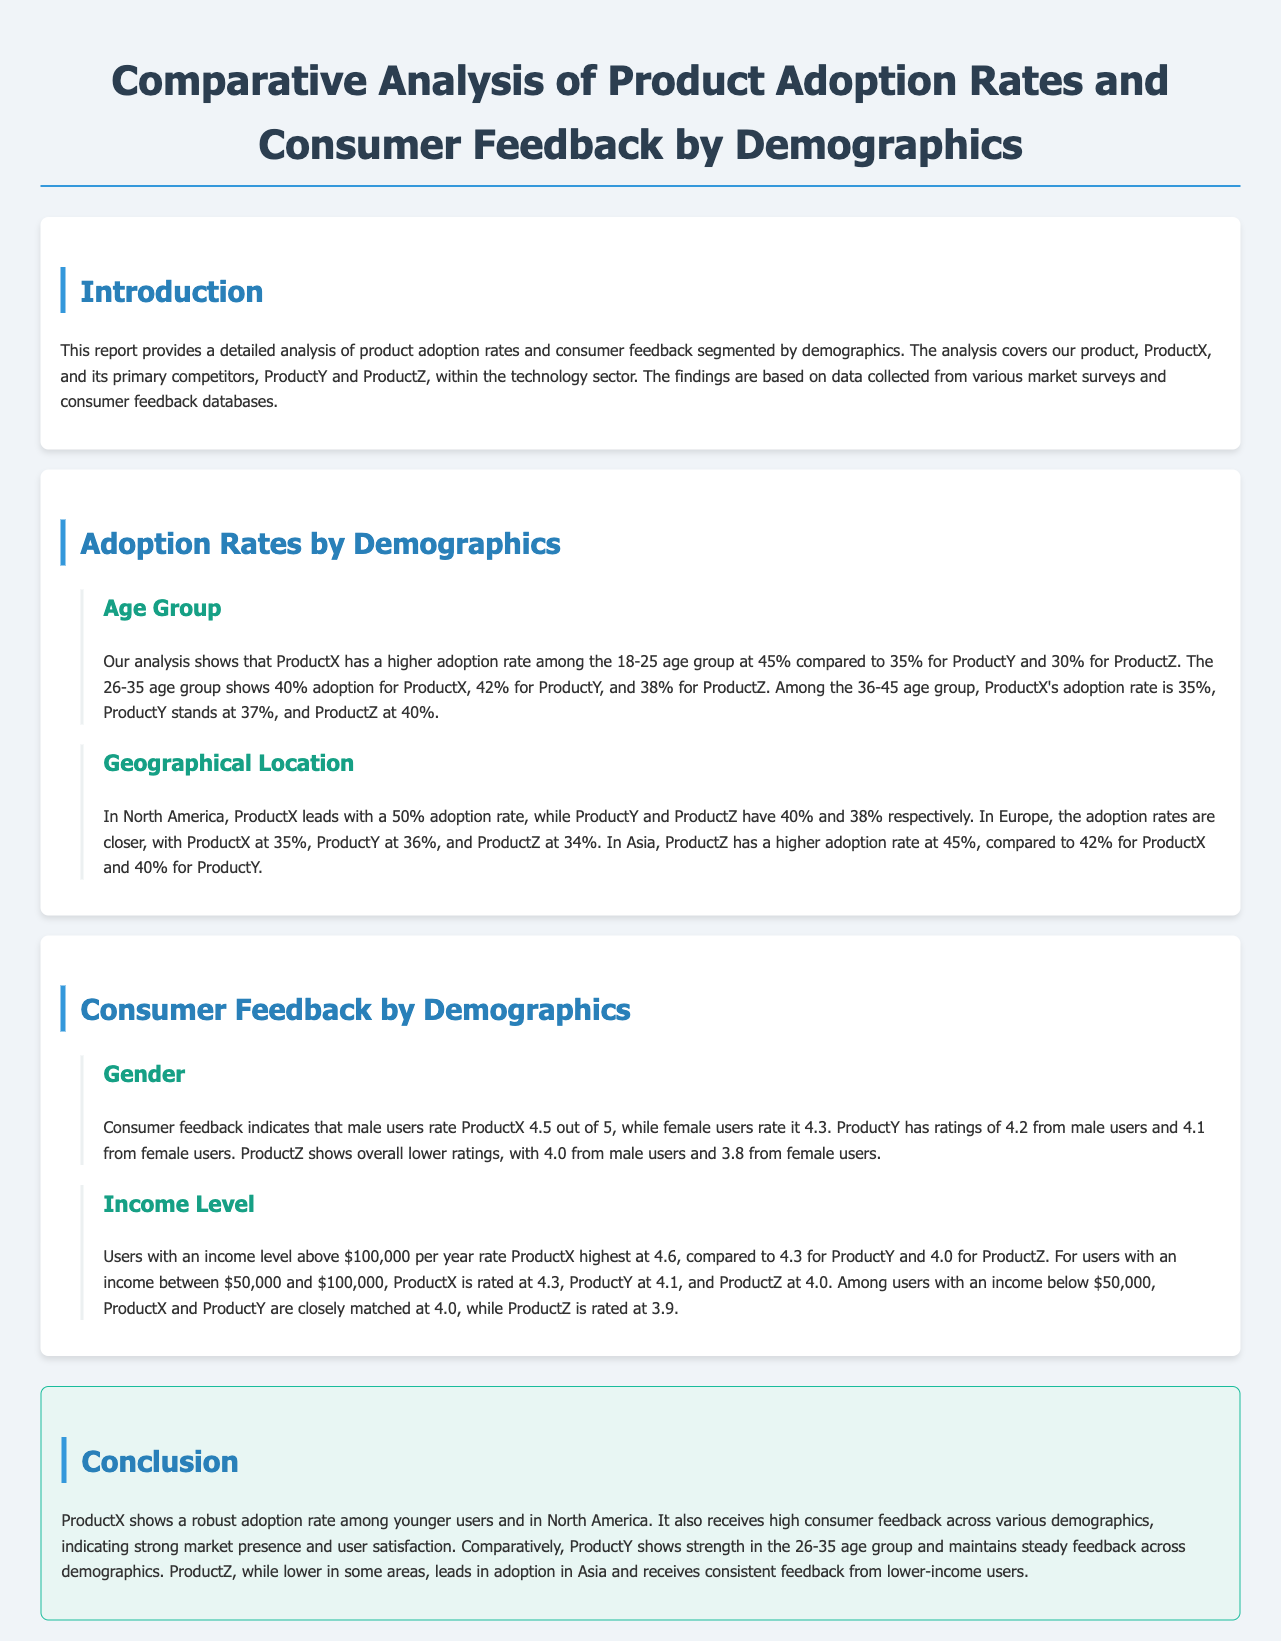What is the adoption rate of ProductX among the 18-25 age group? The document states that ProductX has a higher adoption rate among the 18-25 age group at 45%.
Answer: 45% What is the consumer rating of ProductY from male users? The document indicates that male users rate ProductY 4.2 out of 5.
Answer: 4.2 Which product has the highest adoption rate in North America? The analysis shows that ProductX leads with a 50% adoption rate in North America.
Answer: ProductX What is the rating of ProductX from users with an income above $100,000? It is mentioned that users with an income level above $100,000 per year rate ProductX highest at 4.6.
Answer: 4.6 In which geographical region does ProductZ have a higher adoption rate than ProductX? The document mentions that in Asia, ProductZ has a higher adoption rate at 45%.
Answer: Asia What is the adoption rate of ProductY in the 26-35 age group? The document states ProductY has an adoption rate of 42% in the 26-35 age group.
Answer: 42% Which product shows strong market presence among younger users? The conclusion states that ProductX shows a robust adoption rate among younger users.
Answer: ProductX What is the rating of ProductZ from female users? The document indicates that female users rate ProductZ 3.8 out of 5.
Answer: 3.8 Which product has consistent feedback from lower-income users? The conclusion mentions that ProductZ receives consistent feedback from lower-income users.
Answer: ProductZ 